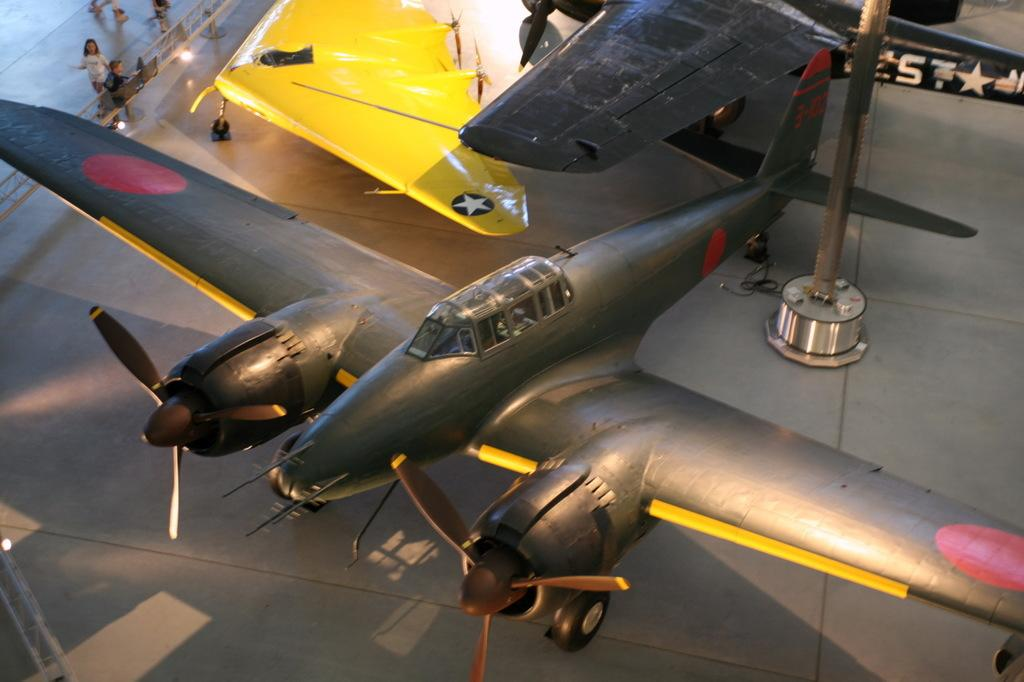What is the main subject of the image? The main subject of the image is aircrafts. Where are the people located in the image? The people are at the top left of the image. What is present at the top left of the image besides the people? There is a railing at the top left of the image. How many cacti can be seen growing near the aircrafts in the image? There are no cacti present in the image. What type of hands are visible on the people in the image? The image does not show the hands of the people, only their presence. 